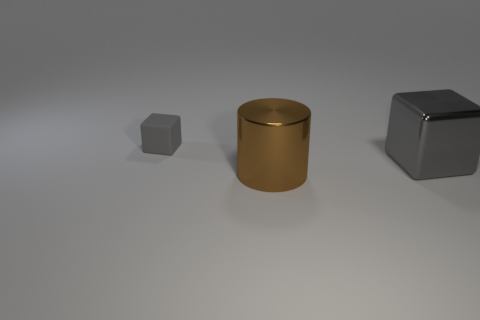Add 3 big cyan matte cylinders. How many objects exist? 6 Subtract all cubes. How many objects are left? 1 Add 1 shiny cylinders. How many shiny cylinders exist? 2 Subtract 0 red cylinders. How many objects are left? 3 Subtract all big brown metallic things. Subtract all large brown metallic cylinders. How many objects are left? 1 Add 2 gray metal objects. How many gray metal objects are left? 3 